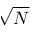Convert formula to latex. <formula><loc_0><loc_0><loc_500><loc_500>\sqrt { N }</formula> 